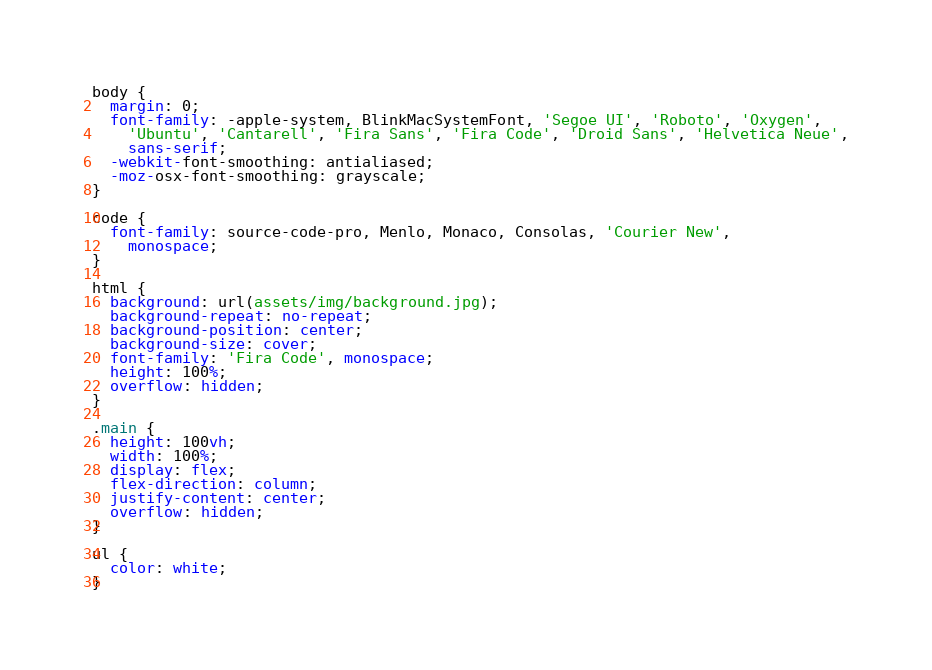<code> <loc_0><loc_0><loc_500><loc_500><_CSS_>body {
  margin: 0;
  font-family: -apple-system, BlinkMacSystemFont, 'Segoe UI', 'Roboto', 'Oxygen',
    'Ubuntu', 'Cantarell', 'Fira Sans', 'Fira Code', 'Droid Sans', 'Helvetica Neue',
    sans-serif;
  -webkit-font-smoothing: antialiased;
  -moz-osx-font-smoothing: grayscale;
}

code {
  font-family: source-code-pro, Menlo, Monaco, Consolas, 'Courier New',
    monospace;
}

html {
  background: url(assets/img/background.jpg);
  background-repeat: no-repeat;
  background-position: center;
  background-size: cover;
  font-family: 'Fira Code', monospace;
  height: 100%;
  overflow: hidden;
}

.main {
  height: 100vh;
  width: 100%;
  display: flex;
  flex-direction: column;
  justify-content: center;
  overflow: hidden;
}

ul {
  color: white;
}</code> 